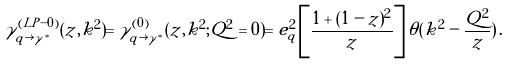Convert formula to latex. <formula><loc_0><loc_0><loc_500><loc_500>\gamma _ { q \rightarrow \gamma ^ { * } } ^ { ( L P - 0 ) } ( z , k ^ { 2 } ) = \gamma _ { q \rightarrow \gamma ^ { * } } ^ { ( 0 ) } ( z , k ^ { 2 } ; Q ^ { 2 } = 0 ) = e _ { q } ^ { 2 } \left [ \frac { 1 + ( 1 - z ) ^ { 2 } } { z } \right ] \theta ( k ^ { 2 } - \frac { Q ^ { 2 } } { z } ) \, .</formula> 